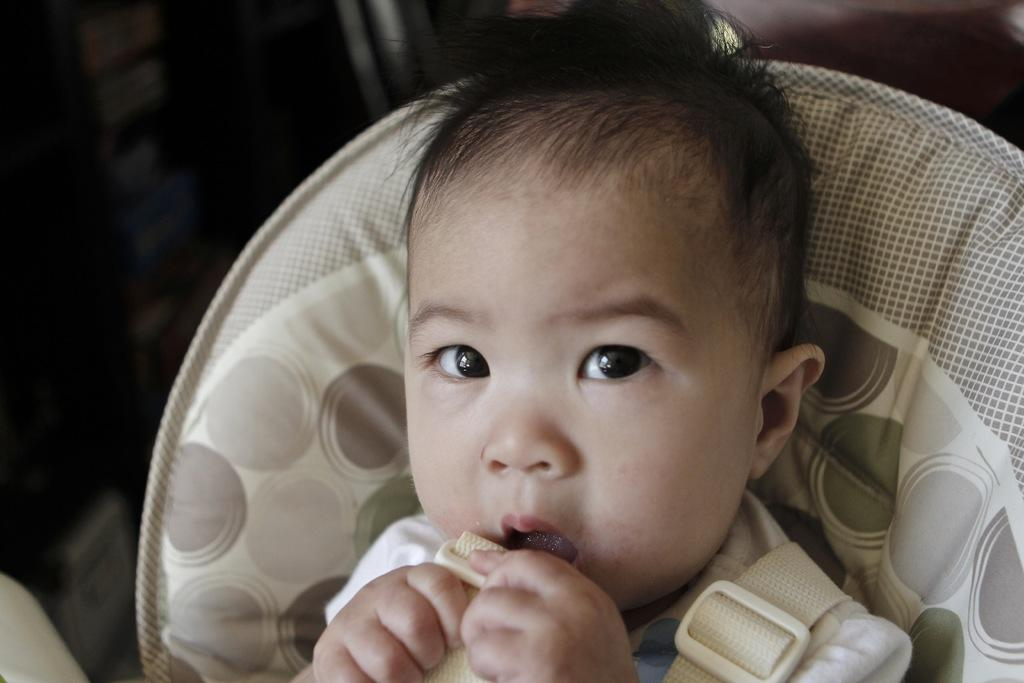Who is the main subject in the image? There is a boy in the image. What is the boy wearing? The boy is wearing white clothing. What can be observed about the background of the image? The background of the image is dark. What type of kiss is the boy giving in the image? There is no kiss present in the image; it only features a boy wearing white clothing with a dark background. 